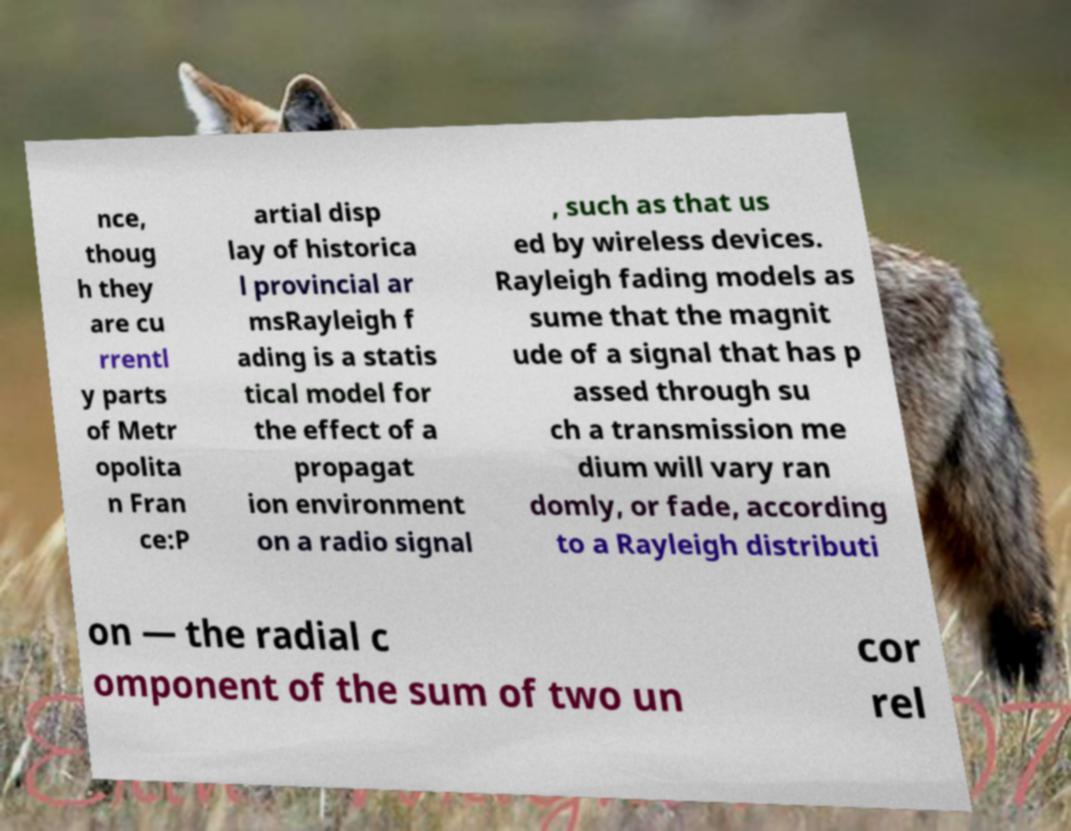Can you accurately transcribe the text from the provided image for me? nce, thoug h they are cu rrentl y parts of Metr opolita n Fran ce:P artial disp lay of historica l provincial ar msRayleigh f ading is a statis tical model for the effect of a propagat ion environment on a radio signal , such as that us ed by wireless devices. Rayleigh fading models as sume that the magnit ude of a signal that has p assed through su ch a transmission me dium will vary ran domly, or fade, according to a Rayleigh distributi on — the radial c omponent of the sum of two un cor rel 